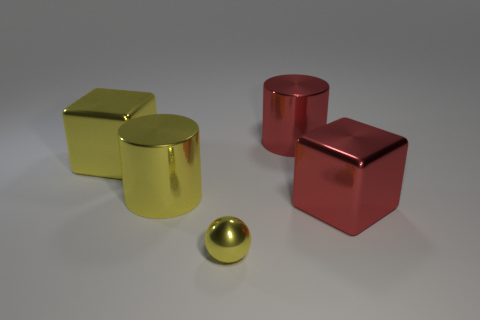What is the color of the metal block to the right of the large metallic cylinder that is right of the small yellow metallic thing?
Keep it short and to the point. Red. The small metallic ball is what color?
Provide a short and direct response. Yellow. Is there a shiny block that has the same color as the small metal object?
Offer a very short reply. Yes. Do the large block on the left side of the small yellow object and the small metallic sphere have the same color?
Give a very brief answer. Yes. How many objects are big metal blocks that are to the left of the yellow ball or metallic cubes?
Your response must be concise. 2. Are there any shiny cubes on the left side of the small metallic sphere?
Your response must be concise. Yes. There is a big shiny block that is in front of the big metallic block on the left side of the tiny metal sphere; are there any large red cylinders behind it?
Ensure brevity in your answer.  Yes. How many cylinders are either large red objects or yellow objects?
Provide a short and direct response. 2. There is a cube that is in front of the big yellow metal block; is its color the same as the shiny cube that is on the left side of the tiny yellow object?
Your answer should be very brief. No. What number of things are shiny balls or yellow metal objects?
Your answer should be compact. 3. 